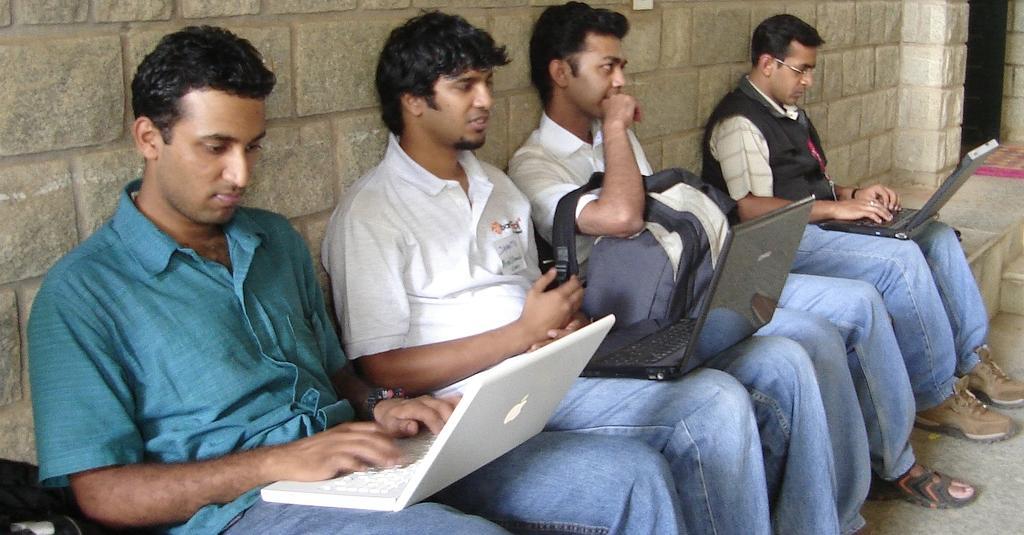Please provide a concise description of this image. In this picture we can see four men sitting on a platform with laptops on them and in the background we can see wall. 